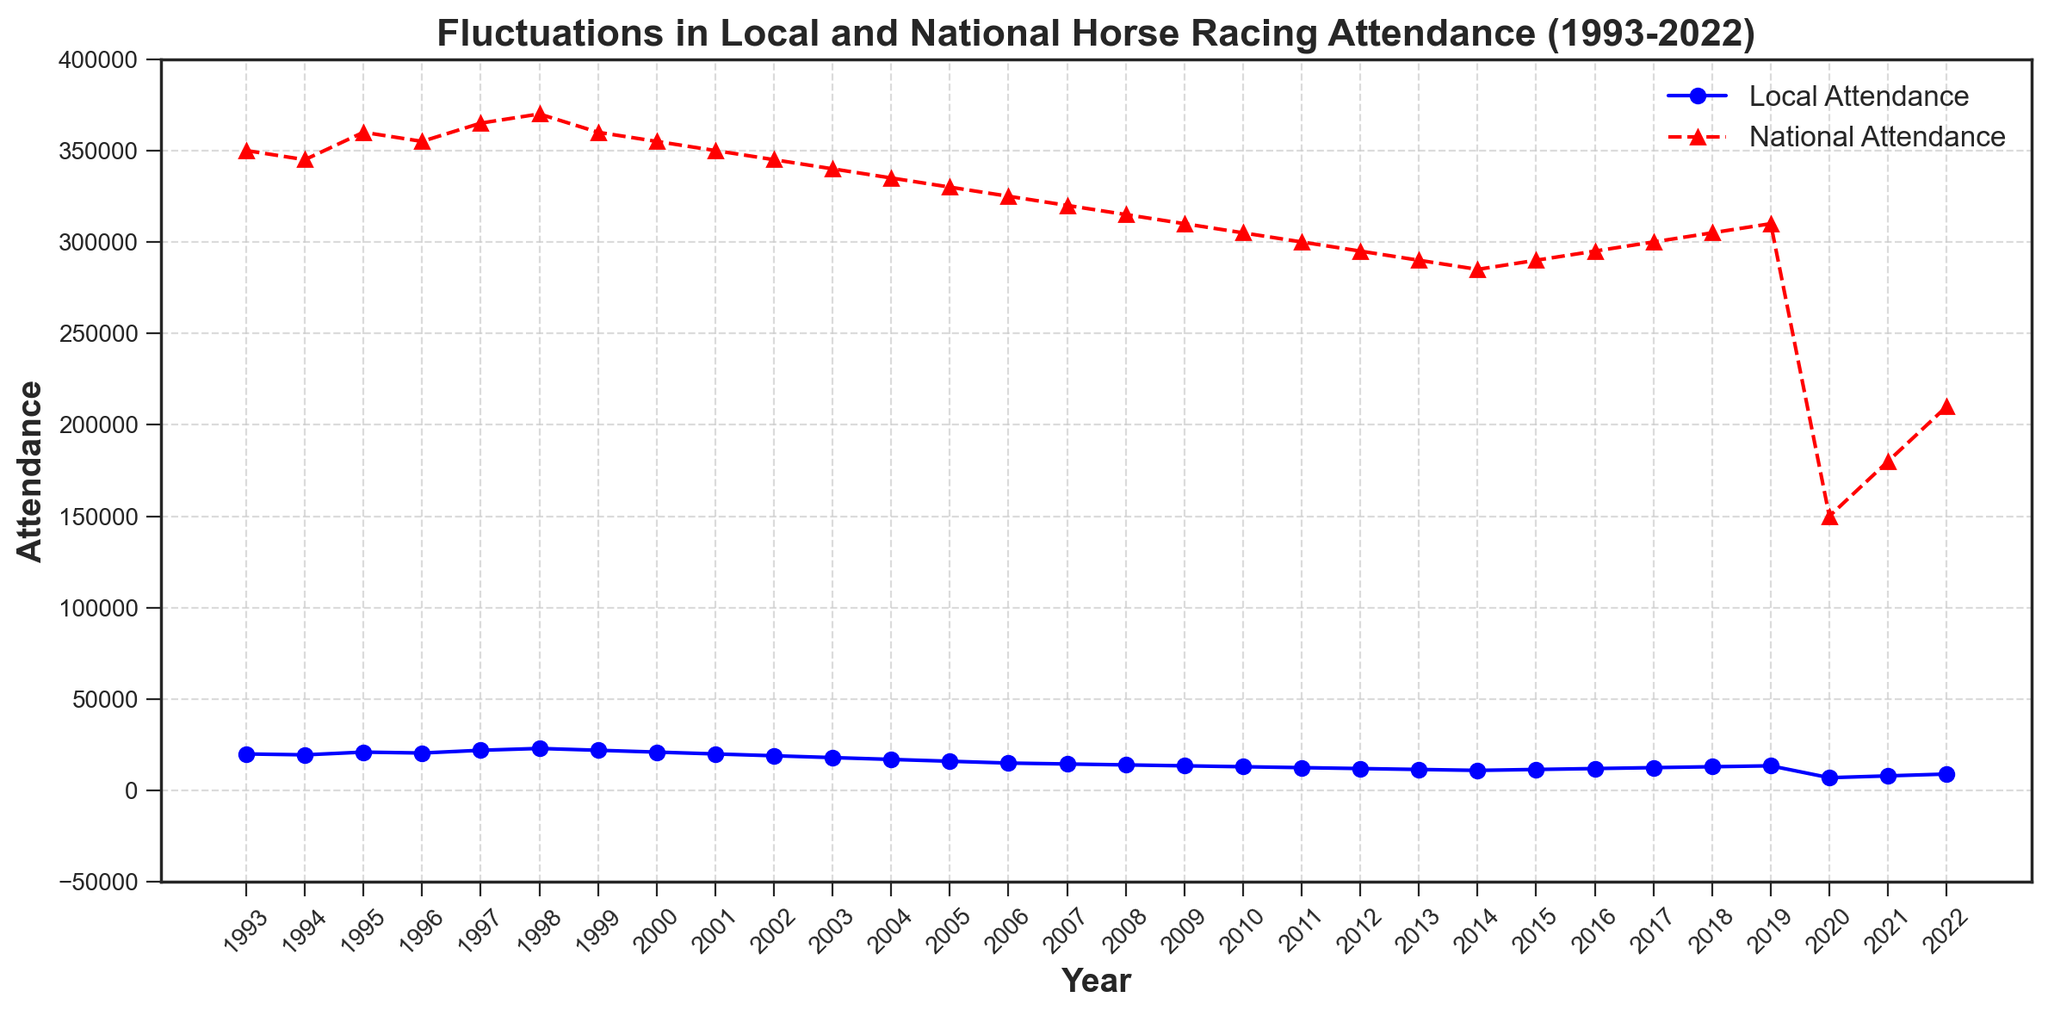How has local attendance changed from 1993 to 2022? In 1993, the local attendance was 20,000. By 2022, it had decreased to 9,000. Therefore, the local attendance declined by 11,000 over the 30-year period.
Answer: It decreased by 11,000 What year saw the lowest national attendance and what was the value? By inspecting the lowest point on the red-dashed line for national attendance, it can be observed that the year 2020 saw the lowest national attendance with a value of 150,000.
Answer: 2020, 150,000 Was there ever a year when local attendance was higher than 25,000? By inspecting the blue-solid line for local attendance, we can see that it never crosses above 25,000 during the entire span from 1993 to 2022.
Answer: No Compare the national attendance in 2019 and 2020. How much did it change? In 2019, the national attendance was 310,000 and in 2020, it was 150,000. The change is calculated as 310,000 - 150,000 = 160,000.
Answer: It decreased by 160,000 What was the average local attendance for the years 1993, 2000, and 2010? First, locate the local attendance values for the years 1993 (20,000), 2000 (21,000), and 2010 (13,000). Then, calculate the average as (20,000 + 21,000 + 13,000) / 3 = 54,000 / 3 = 18,000.
Answer: 18,000 In which year did both local and national attendance show a noticeable decrease compared to the previous year? In 2020, both local and national attendance dropped significantly compared to 2019. Local attendance dropped from 13,500 to 7,000, and national attendance dropped from 310,000 to 150,000.
Answer: 2020 What was the overall trend of national attendance from 1993 to 2012? From 1993 to 2012, the national attendance generally decreased. It started at 350,000 in 1993 and declined progressively until it reached 295,000 in 2012.
Answer: It decreased Which period shows a continuous decline in local attendance? From 1998 to 2014, the local attendance consistently declined every year.
Answer: 1998 to 2014 How does the decline in local attendance in the first decade (1993-2003) compare to the decline in the second decade (2003-2013)? In the first decade, local attendance declined from 20,000 to 18,000, a difference of 2,000. In the second decade, it declined from 18,000 to 11,500, a difference of 6,500. Therefore, the decline was greater in the second decade.
Answer: Greater in second decade What is the visual difference between the trends of local and national attendance during the COVID-19 pandemic years (2020-2022)? During the years 2020-2022, both the blue-solid line (local attendance) and the red-dashed line (national attendance) show a steep decline and a slow recovery. National attendance (red-dashed line) shows a more dramatic drop compared to local attendance (blue-solid line).
Answer: Steep decline and slow recovery for both, more dramatic drop for national attendance 